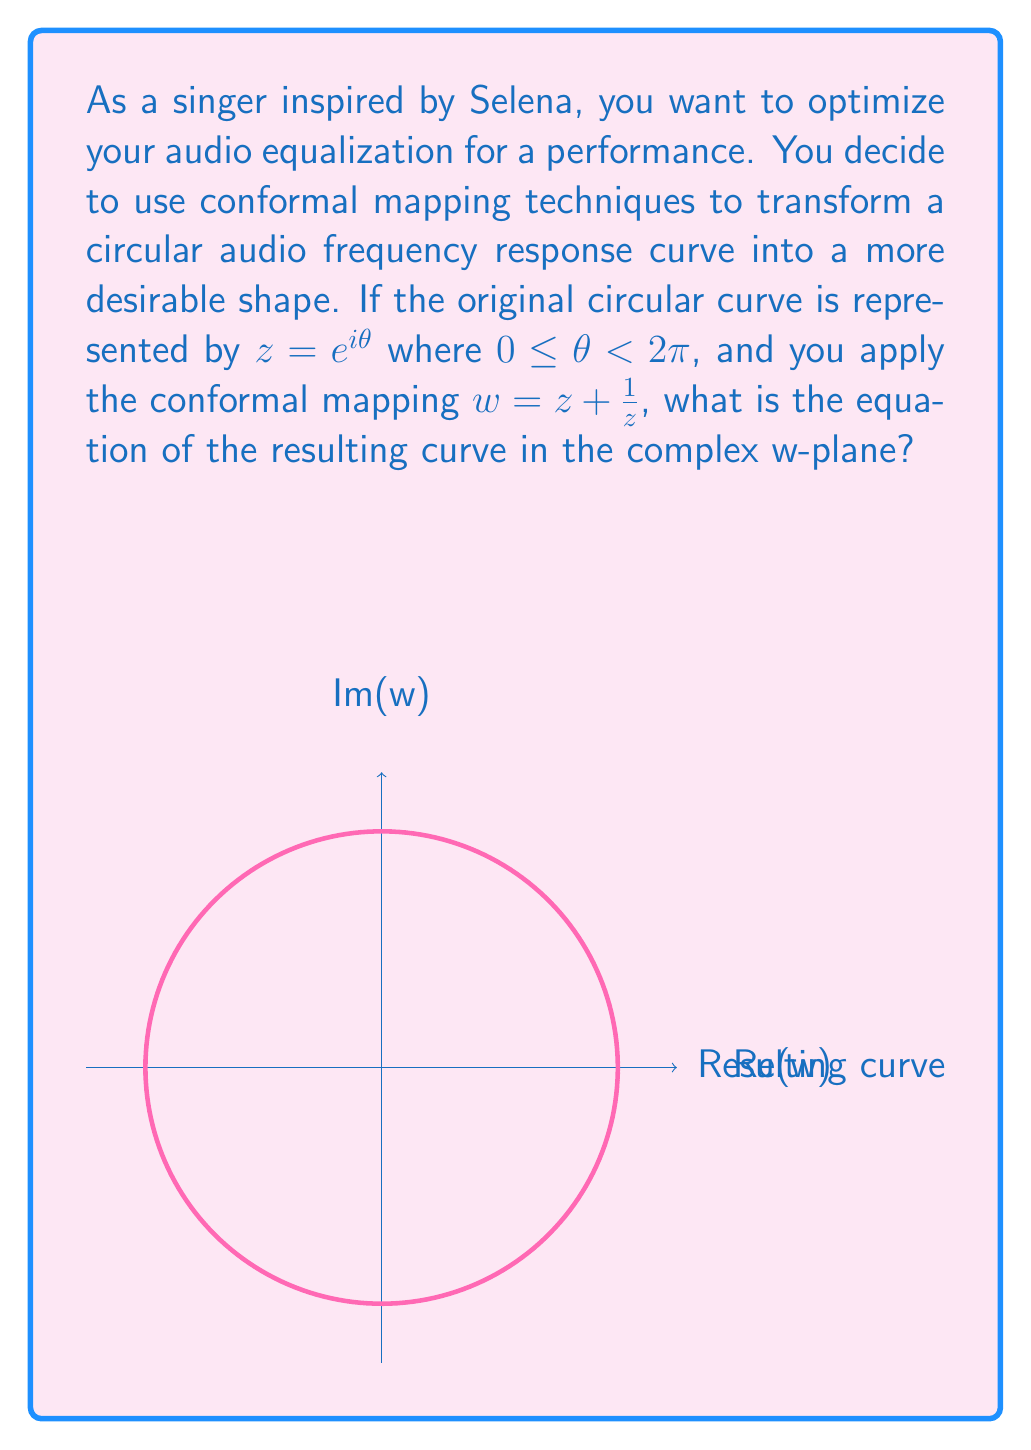What is the answer to this math problem? Let's approach this step-by-step:

1) We start with the circular curve $z = e^{i\theta}$, where $0 \leq \theta < 2\pi$.

2) The conformal mapping is given by $w = z + \frac{1}{z}$.

3) We need to substitute $z = e^{i\theta}$ into this mapping:

   $w = e^{i\theta} + \frac{1}{e^{i\theta}}$

4) Recall Euler's formula: $e^{i\theta} = \cos\theta + i\sin\theta$

5) Using this, we can rewrite the equation:

   $w = (\cos\theta + i\sin\theta) + \frac{1}{\cos\theta + i\sin\theta}$

6) To simplify the fraction, multiply numerator and denominator by the complex conjugate:

   $w = (\cos\theta + i\sin\theta) + \frac{\cos\theta - i\sin\theta}{\cos^2\theta + \sin^2\theta}$

7) Recall that $\cos^2\theta + \sin^2\theta = 1$, so this simplifies to:

   $w = (\cos\theta + i\sin\theta) + (\cos\theta - i\sin\theta)$

8) Combining like terms:

   $w = 2\cos\theta + 0i$

9) Therefore, the real part of w is $2\cos\theta$ and the imaginary part is 0.

10) This is the parametric form of the equation. To get the Cartesian form, we can square both sides:

    $w^2 = 4\cos^2\theta = 4(1-\sin^2\theta) = 4 - 4\sin^2\theta$

11) Rearranging:

    $4\sin^2\theta = 4 - w^2$

12) Dividing by 4:

    $\sin^2\theta = 1 - \frac{w^2}{4}$

This is the equation of the resulting curve in the w-plane.
Answer: $\sin^2\theta = 1 - \frac{w^2}{4}$ 